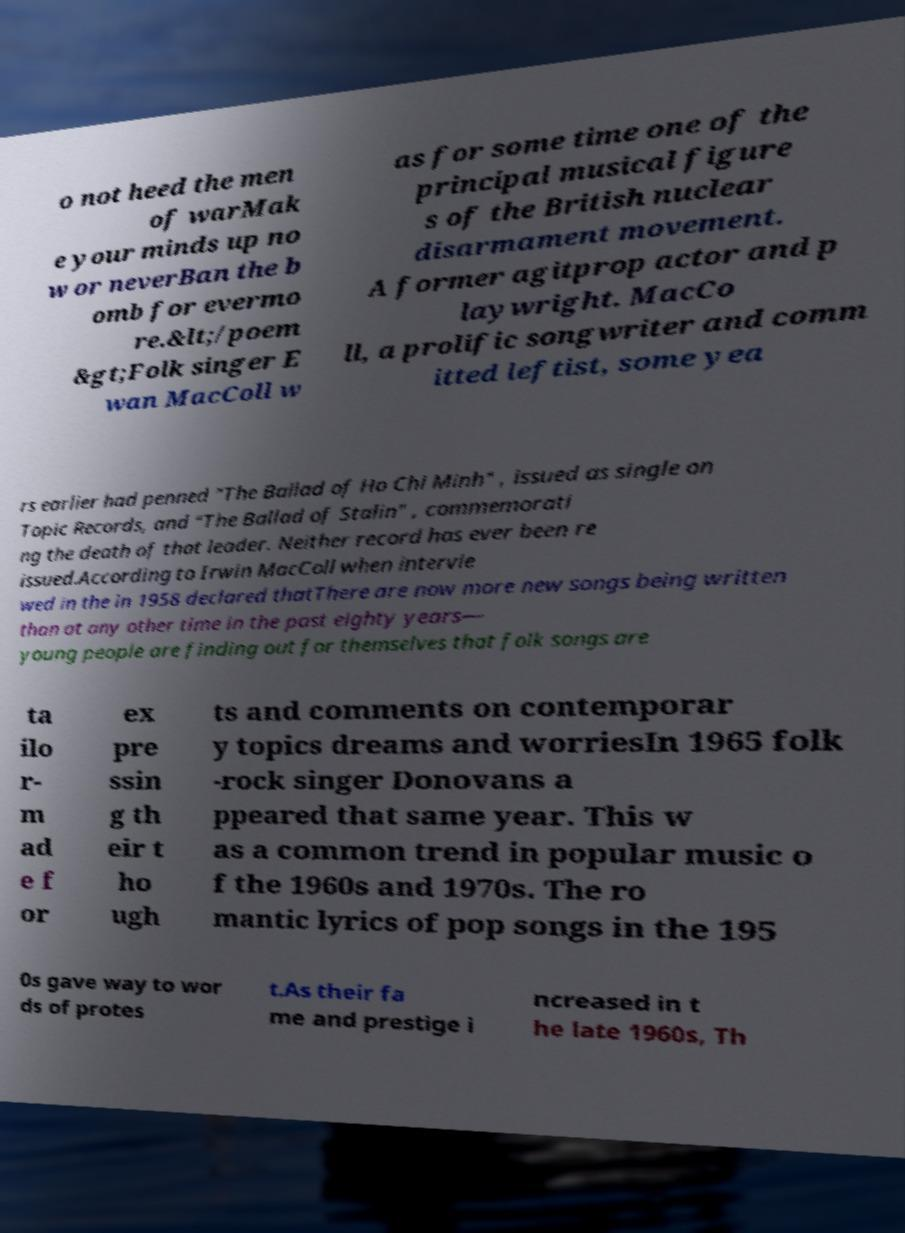Can you read and provide the text displayed in the image?This photo seems to have some interesting text. Can you extract and type it out for me? o not heed the men of warMak e your minds up no w or neverBan the b omb for evermo re.&lt;/poem &gt;Folk singer E wan MacColl w as for some time one of the principal musical figure s of the British nuclear disarmament movement. A former agitprop actor and p laywright. MacCo ll, a prolific songwriter and comm itted leftist, some yea rs earlier had penned "The Ballad of Ho Chi Minh" , issued as single on Topic Records, and "The Ballad of Stalin" , commemorati ng the death of that leader. Neither record has ever been re issued.According to Irwin MacColl when intervie wed in the in 1958 declared thatThere are now more new songs being written than at any other time in the past eighty years— young people are finding out for themselves that folk songs are ta ilo r- m ad e f or ex pre ssin g th eir t ho ugh ts and comments on contemporar y topics dreams and worriesIn 1965 folk -rock singer Donovans a ppeared that same year. This w as a common trend in popular music o f the 1960s and 1970s. The ro mantic lyrics of pop songs in the 195 0s gave way to wor ds of protes t.As their fa me and prestige i ncreased in t he late 1960s, Th 